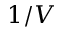<formula> <loc_0><loc_0><loc_500><loc_500>1 / V</formula> 